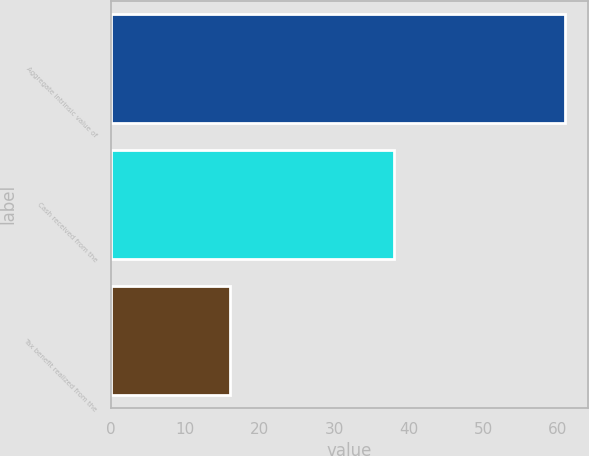<chart> <loc_0><loc_0><loc_500><loc_500><bar_chart><fcel>Aggregate intrinsic value of<fcel>Cash received from the<fcel>Tax benefit realized from the<nl><fcel>61<fcel>38<fcel>16<nl></chart> 